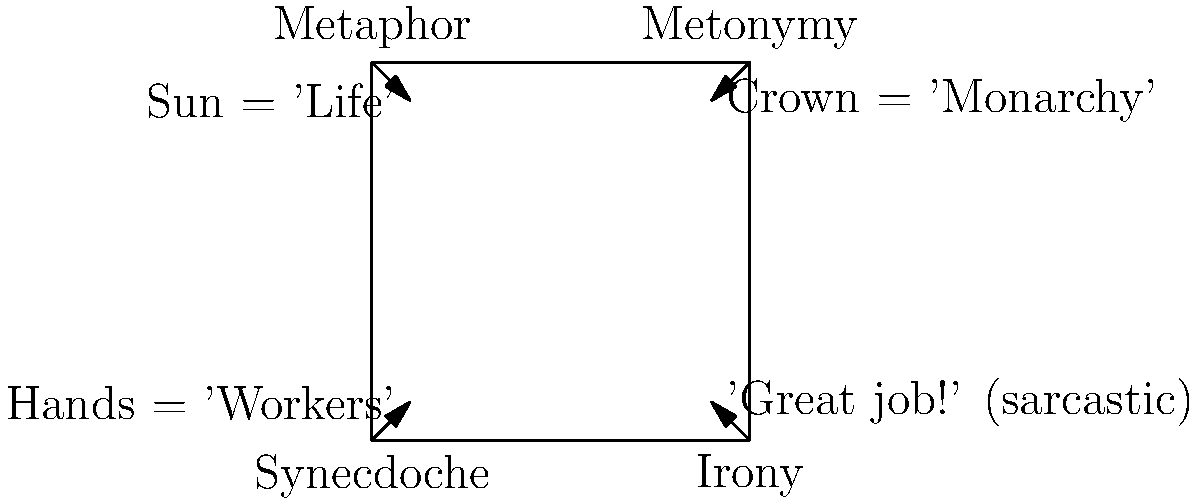In the comparison chart of Burke's Four Master Tropes, which trope is directly opposite to Metaphor, and how does its example differ in terms of representational strategy? To answer this question, let's analyze the chart step-by-step:

1. Identify the tropes: The chart shows Burke's Four Master Tropes - Metaphor, Metonymy, Synecdoche, and Irony.

2. Locate Metaphor: Metaphor is positioned at the top-left corner of the chart.

3. Find the opposite trope: The trope directly opposite to Metaphor is Irony, located at the bottom-right corner.

4. Compare examples:
   - Metaphor example: "Sun = 'Life'" - This represents a direct comparison between two unlike things based on a shared quality (e.g., the sun gives life, warmth, energy).
   - Irony example: "'Great job!' (sarcastic)" - This represents saying one thing while meaning the opposite, often used to criticize or mock.

5. Analyze representational strategies:
   - Metaphor uses similarity or analogy to represent one concept in terms of another.
   - Irony uses contradiction or incongruity to represent meaning that is opposite to the literal statement.

The key difference is that Metaphor creates a straightforward, often positive association, while Irony creates a tension between the stated and intended meanings, often for critical or humorous effect.
Answer: Irony; Metaphor uses similarity, Irony uses contradiction. 